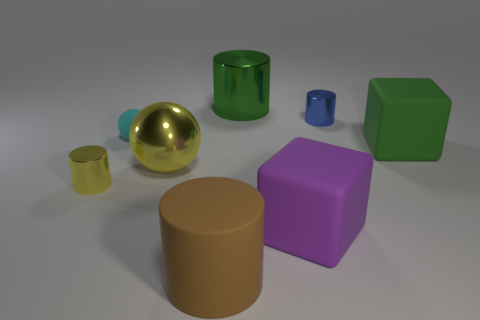Add 1 blue shiny things. How many objects exist? 9 Subtract all cubes. How many objects are left? 6 Subtract all big purple objects. Subtract all big brown matte objects. How many objects are left? 6 Add 6 green cylinders. How many green cylinders are left? 7 Add 4 green matte cubes. How many green matte cubes exist? 5 Subtract 1 yellow cylinders. How many objects are left? 7 